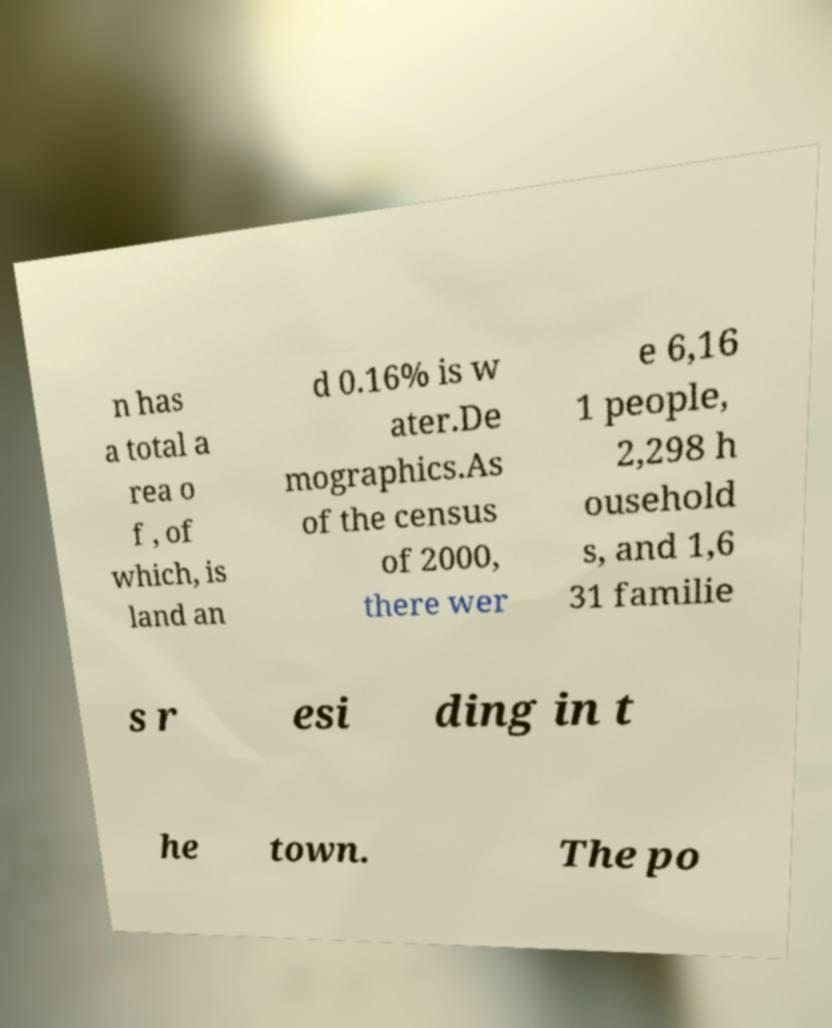There's text embedded in this image that I need extracted. Can you transcribe it verbatim? n has a total a rea o f , of which, is land an d 0.16% is w ater.De mographics.As of the census of 2000, there wer e 6,16 1 people, 2,298 h ousehold s, and 1,6 31 familie s r esi ding in t he town. The po 